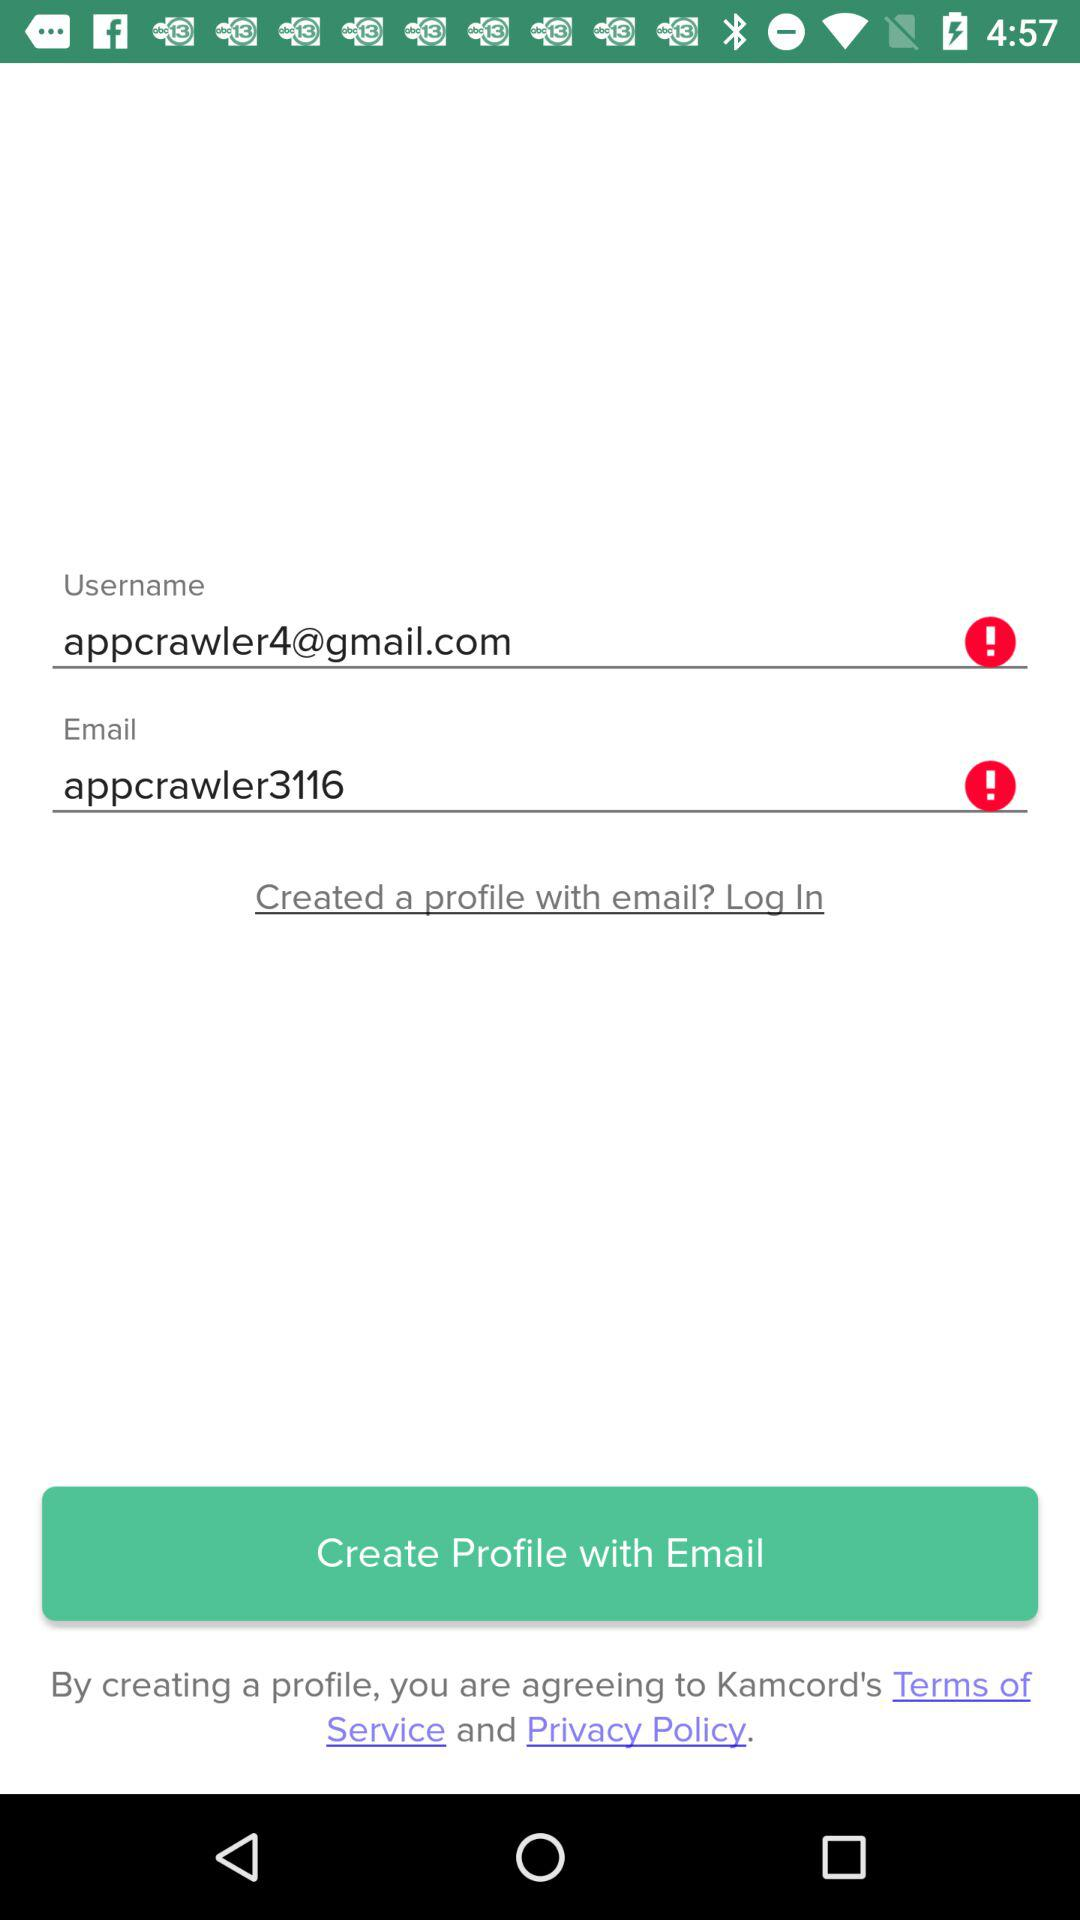What is the email address? The email address is appcrawler4@gmail.com. 